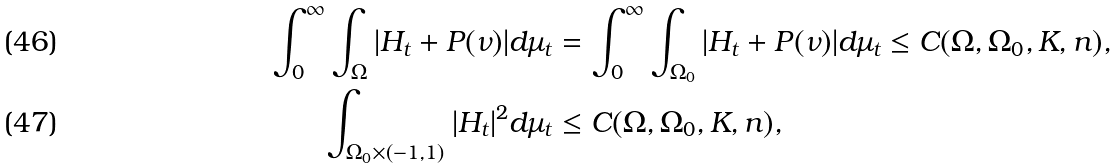<formula> <loc_0><loc_0><loc_500><loc_500>\int _ { 0 } ^ { \infty } \int _ { \Omega } | H _ { t } + P ( \nu ) | d \mu _ { t } & = \int _ { 0 } ^ { \infty } \int _ { \Omega _ { 0 } } | H _ { t } + P ( \nu ) | d \mu _ { t } \leq C ( \Omega , \Omega _ { 0 } , K , n ) , \\ \int _ { \Omega _ { 0 } \times ( - 1 , 1 ) } | H _ { t } | ^ { 2 } d \mu _ { t } & \leq C ( \Omega , \Omega _ { 0 } , K , n ) ,</formula> 